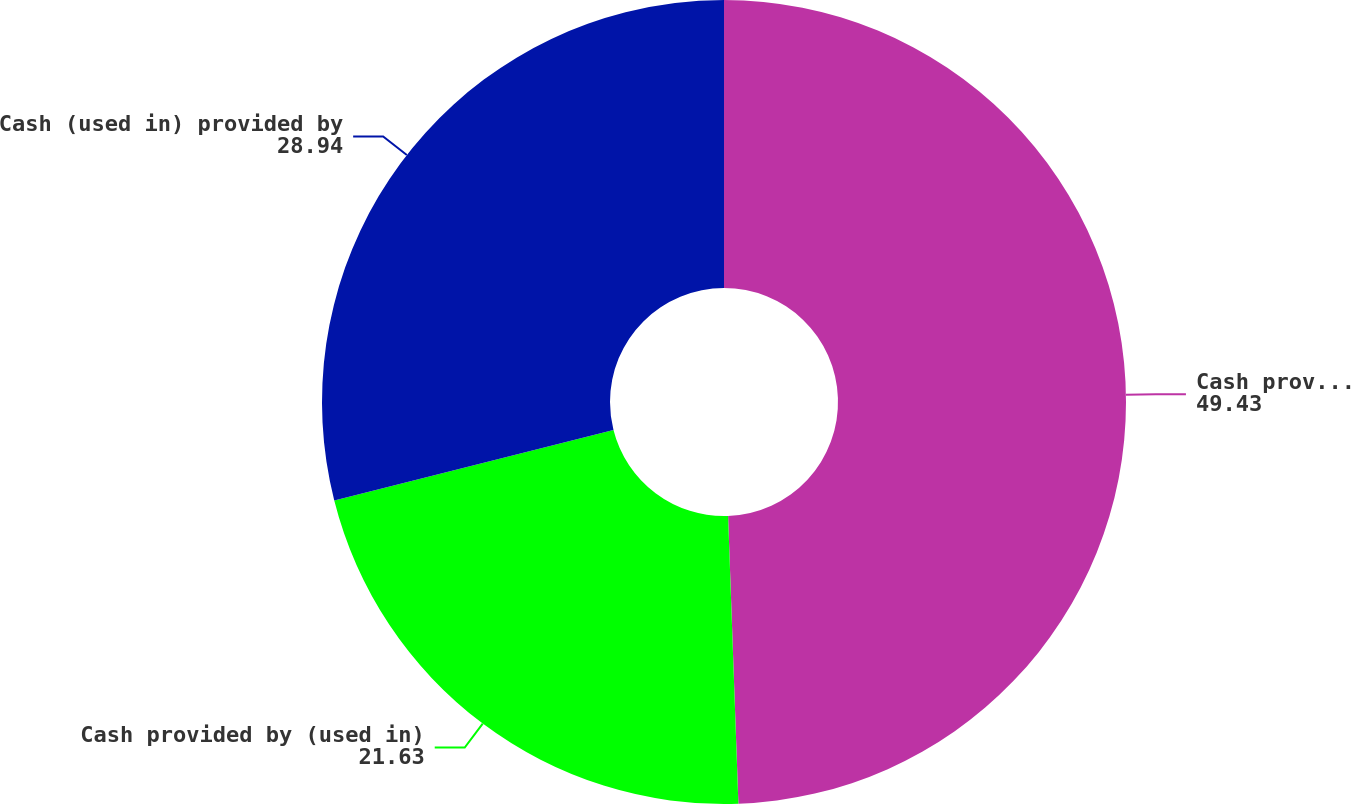<chart> <loc_0><loc_0><loc_500><loc_500><pie_chart><fcel>Cash provided by operating<fcel>Cash provided by (used in)<fcel>Cash (used in) provided by<nl><fcel>49.43%<fcel>21.63%<fcel>28.94%<nl></chart> 